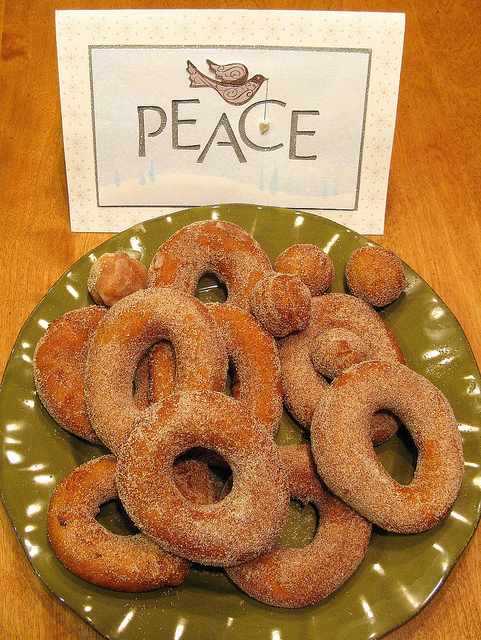Extract all visible text content from this image. PEACE 